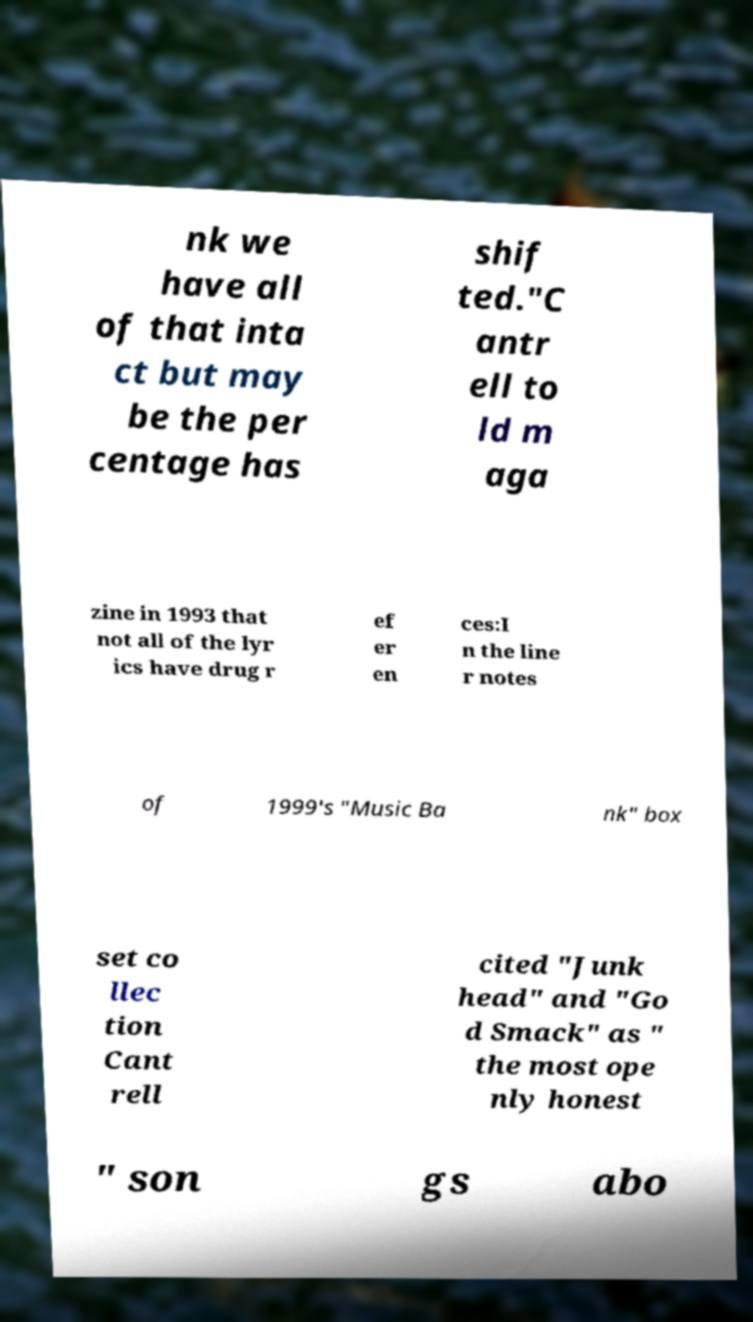There's text embedded in this image that I need extracted. Can you transcribe it verbatim? nk we have all of that inta ct but may be the per centage has shif ted."C antr ell to ld m aga zine in 1993 that not all of the lyr ics have drug r ef er en ces:I n the line r notes of 1999's "Music Ba nk" box set co llec tion Cant rell cited "Junk head" and "Go d Smack" as " the most ope nly honest " son gs abo 